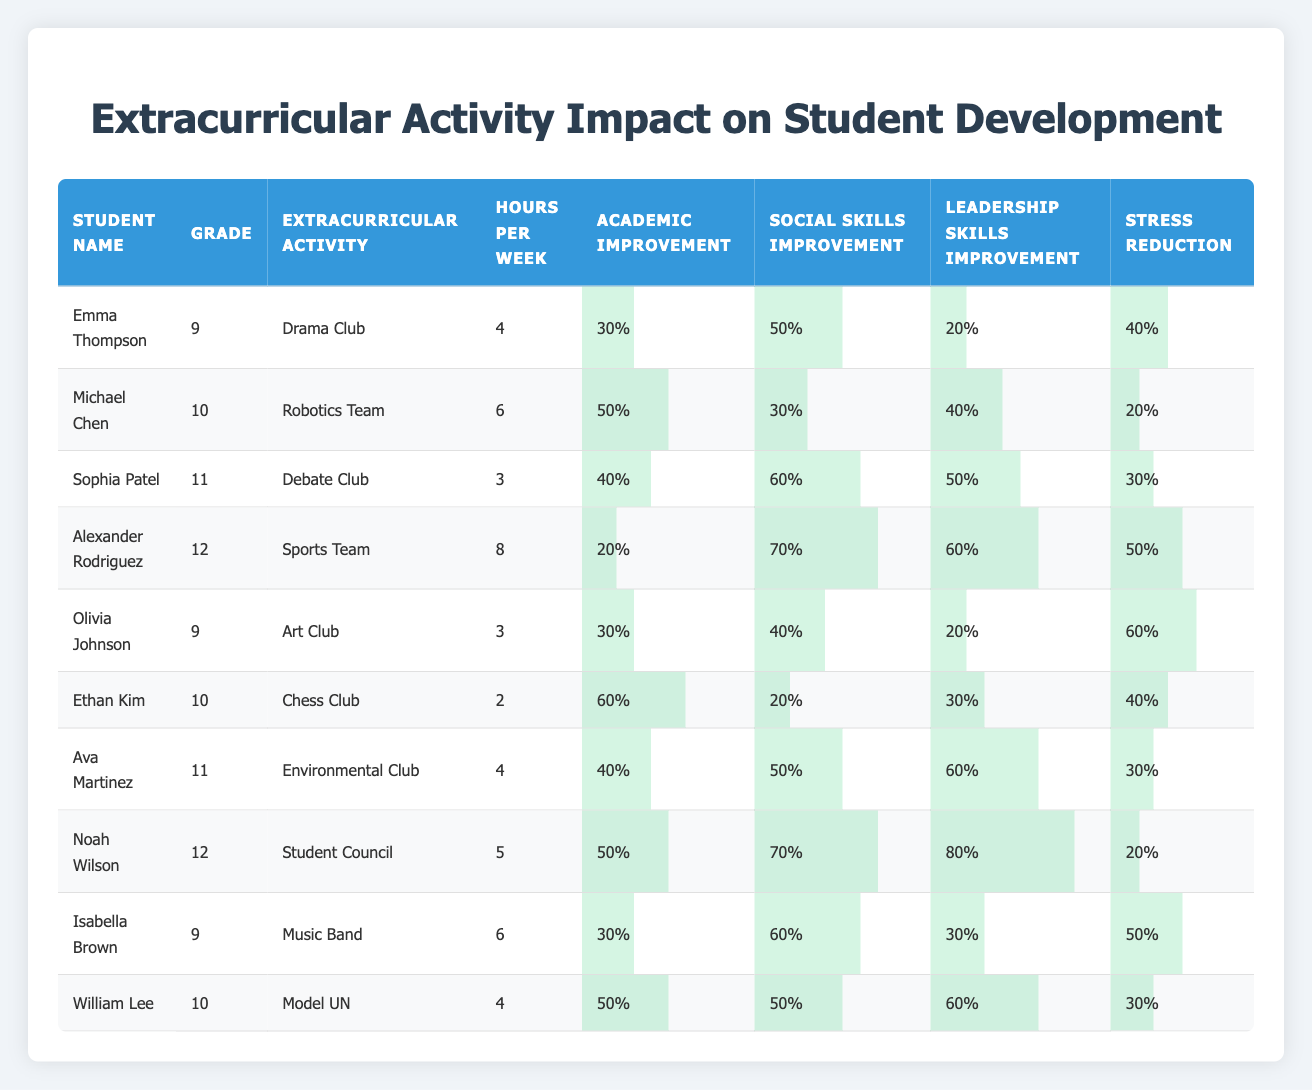What extracurricular activity had the highest social skills improvement? Examining the table, we look at the "Social Skills Improvement" column. The highest value is 80%, which corresponds to Noah Wilson in the "Student Council."
Answer: Student Council What is the total hours per week spent on extracurricular activities by grade 9 students? For grade 9, the students are Emma Thompson, Olivia Johnson, and Isabella Brown, who spend 4, 3, and 6 hours per week respectively. Summing these, we get 4 + 3 + 6 = 13 hours.
Answer: 13 hours Did any student experience a stress reduction of more than 50%? Observing the "Stress Reduction" column, Alexander Rodriguez and Olivia Johnson have 50%, and others are below. Thus, no student reached over 50%.
Answer: No Which extracurricular activity had the lowest academic improvement? We check the "Academic Improvement" column for each activity. The lowest value is 20%, which is associated with Alexander Rodriguez in the "Sports Team."
Answer: Sports Team How many students improved their leadership skills by at least 50%? We count values in the "Leadership Skills Improvement" column greater than or equal to 50%. Students Sophia Patel, Alexander Rodriguez, Ava Martinez, Noah Wilson, and William Lee have 50% or more, totaling 5 students.
Answer: 5 students What is the average academic improvement for students participating in the Debate Club and Model UN? Sophia Patel in Debate Club has 40% academic improvement, while William Lee in Model UN has 50%. Their average is (40 + 50) / 2 = 45%.
Answer: 45% Which grade had students participating in extracurricular activities beyond 5 hours per week? Looking at the "Hours per Week" column for each grade, we find that grade 10 has Michael Chen (6) and Ethan Kim (2), and grade 12 has Alexander Rodriguez (8) and Noah Wilson (5). Grade 12 has a student with more than 5 hours.
Answer: Grade 12 Who had the highest overall improvement in social skills, and what was the percentage? Scanning the "Social Skills Improvement" column, Alexander Rodriguez shows the highest at 70%.
Answer: 70% What is the total average stress reduction for students who are in grade 11? Gathering data for grade 11, we have Ava Martinez (30%) and Sophia Patel (30%). Their average stress reduction is (30 + 30) / 2 = 30%.
Answer: 30% 